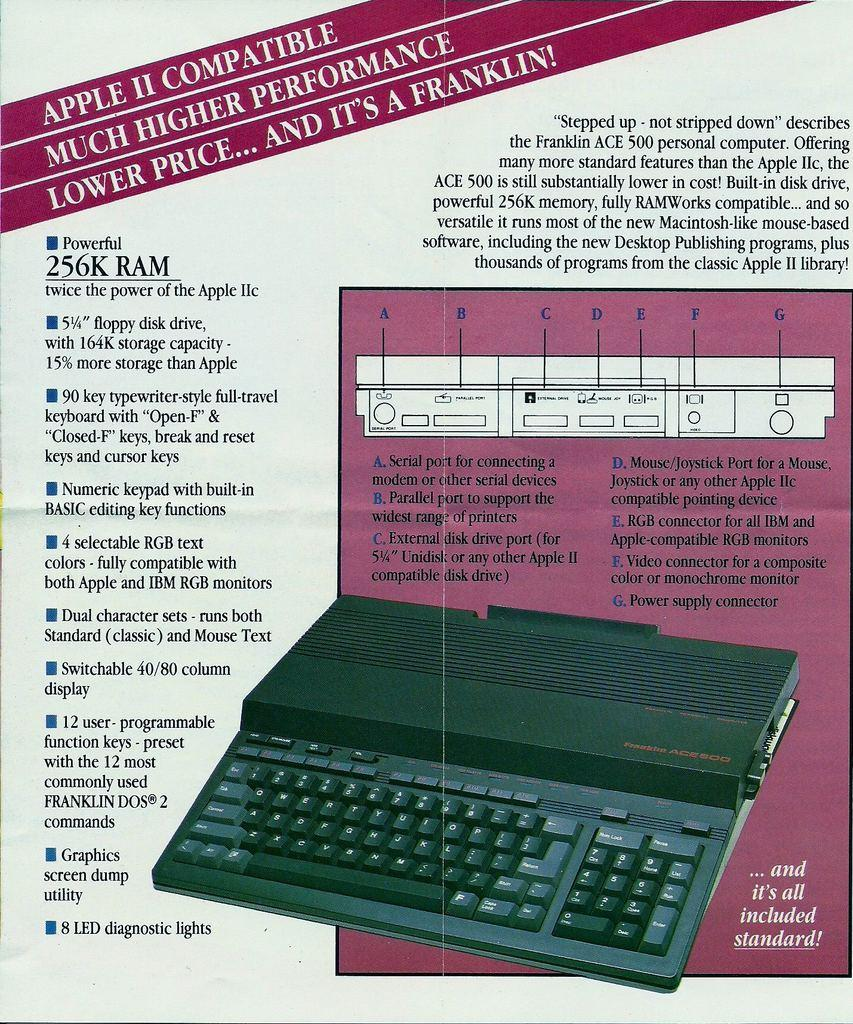Provide a one-sentence caption for the provided image. Poster for a keyboard that says it's Apple II compatible. 